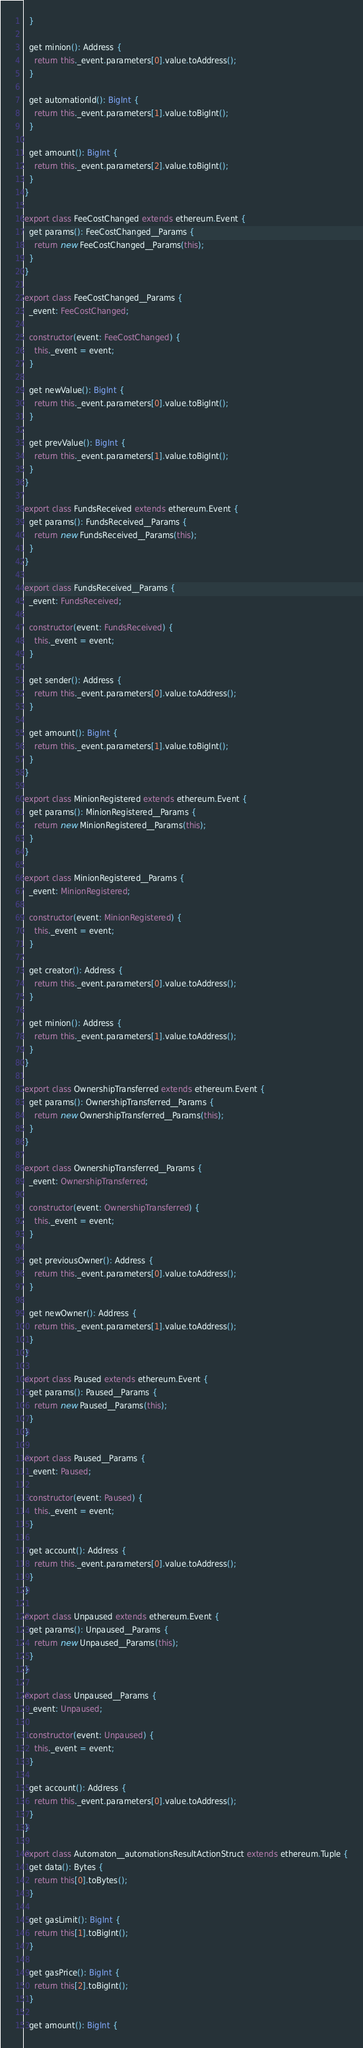<code> <loc_0><loc_0><loc_500><loc_500><_TypeScript_>  }

  get minion(): Address {
    return this._event.parameters[0].value.toAddress();
  }

  get automationId(): BigInt {
    return this._event.parameters[1].value.toBigInt();
  }

  get amount(): BigInt {
    return this._event.parameters[2].value.toBigInt();
  }
}

export class FeeCostChanged extends ethereum.Event {
  get params(): FeeCostChanged__Params {
    return new FeeCostChanged__Params(this);
  }
}

export class FeeCostChanged__Params {
  _event: FeeCostChanged;

  constructor(event: FeeCostChanged) {
    this._event = event;
  }

  get newValue(): BigInt {
    return this._event.parameters[0].value.toBigInt();
  }

  get prevValue(): BigInt {
    return this._event.parameters[1].value.toBigInt();
  }
}

export class FundsReceived extends ethereum.Event {
  get params(): FundsReceived__Params {
    return new FundsReceived__Params(this);
  }
}

export class FundsReceived__Params {
  _event: FundsReceived;

  constructor(event: FundsReceived) {
    this._event = event;
  }

  get sender(): Address {
    return this._event.parameters[0].value.toAddress();
  }

  get amount(): BigInt {
    return this._event.parameters[1].value.toBigInt();
  }
}

export class MinionRegistered extends ethereum.Event {
  get params(): MinionRegistered__Params {
    return new MinionRegistered__Params(this);
  }
}

export class MinionRegistered__Params {
  _event: MinionRegistered;

  constructor(event: MinionRegistered) {
    this._event = event;
  }

  get creator(): Address {
    return this._event.parameters[0].value.toAddress();
  }

  get minion(): Address {
    return this._event.parameters[1].value.toAddress();
  }
}

export class OwnershipTransferred extends ethereum.Event {
  get params(): OwnershipTransferred__Params {
    return new OwnershipTransferred__Params(this);
  }
}

export class OwnershipTransferred__Params {
  _event: OwnershipTransferred;

  constructor(event: OwnershipTransferred) {
    this._event = event;
  }

  get previousOwner(): Address {
    return this._event.parameters[0].value.toAddress();
  }

  get newOwner(): Address {
    return this._event.parameters[1].value.toAddress();
  }
}

export class Paused extends ethereum.Event {
  get params(): Paused__Params {
    return new Paused__Params(this);
  }
}

export class Paused__Params {
  _event: Paused;

  constructor(event: Paused) {
    this._event = event;
  }

  get account(): Address {
    return this._event.parameters[0].value.toAddress();
  }
}

export class Unpaused extends ethereum.Event {
  get params(): Unpaused__Params {
    return new Unpaused__Params(this);
  }
}

export class Unpaused__Params {
  _event: Unpaused;

  constructor(event: Unpaused) {
    this._event = event;
  }

  get account(): Address {
    return this._event.parameters[0].value.toAddress();
  }
}

export class Automaton__automationsResultActionStruct extends ethereum.Tuple {
  get data(): Bytes {
    return this[0].toBytes();
  }

  get gasLimit(): BigInt {
    return this[1].toBigInt();
  }

  get gasPrice(): BigInt {
    return this[2].toBigInt();
  }

  get amount(): BigInt {</code> 